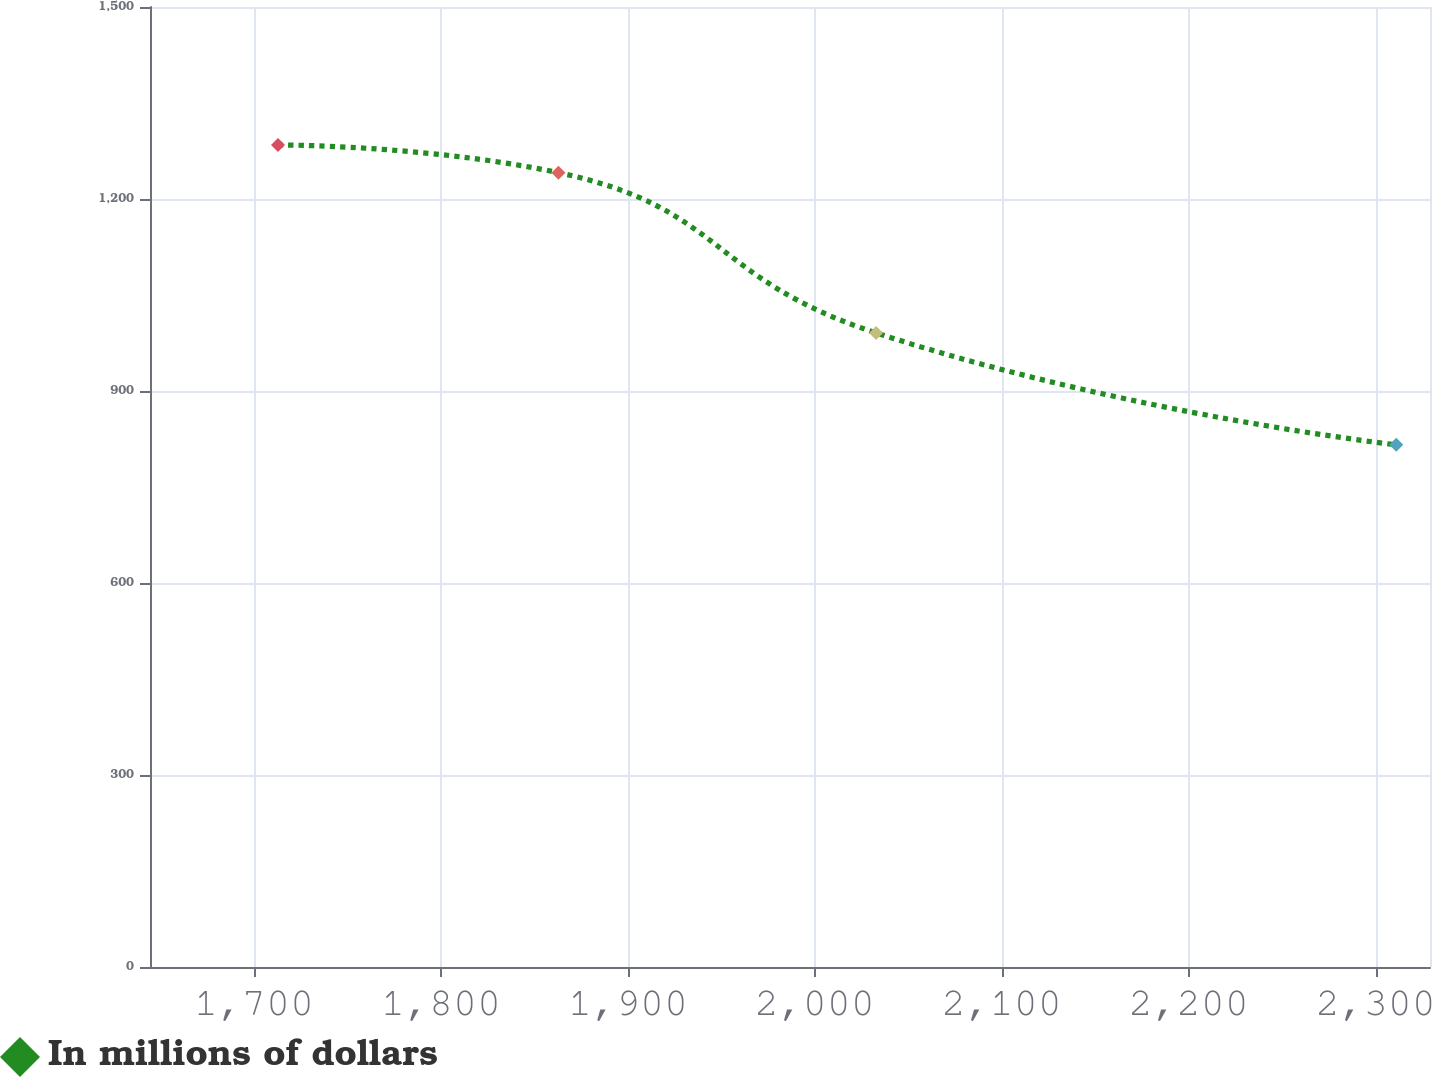Convert chart to OTSL. <chart><loc_0><loc_0><loc_500><loc_500><line_chart><ecel><fcel>In millions of dollars<nl><fcel>1712.79<fcel>1284.45<nl><fcel>1862.81<fcel>1241.16<nl><fcel>2032.73<fcel>990.77<nl><fcel>2311.01<fcel>815.92<nl><fcel>2397.55<fcel>933.06<nl></chart> 